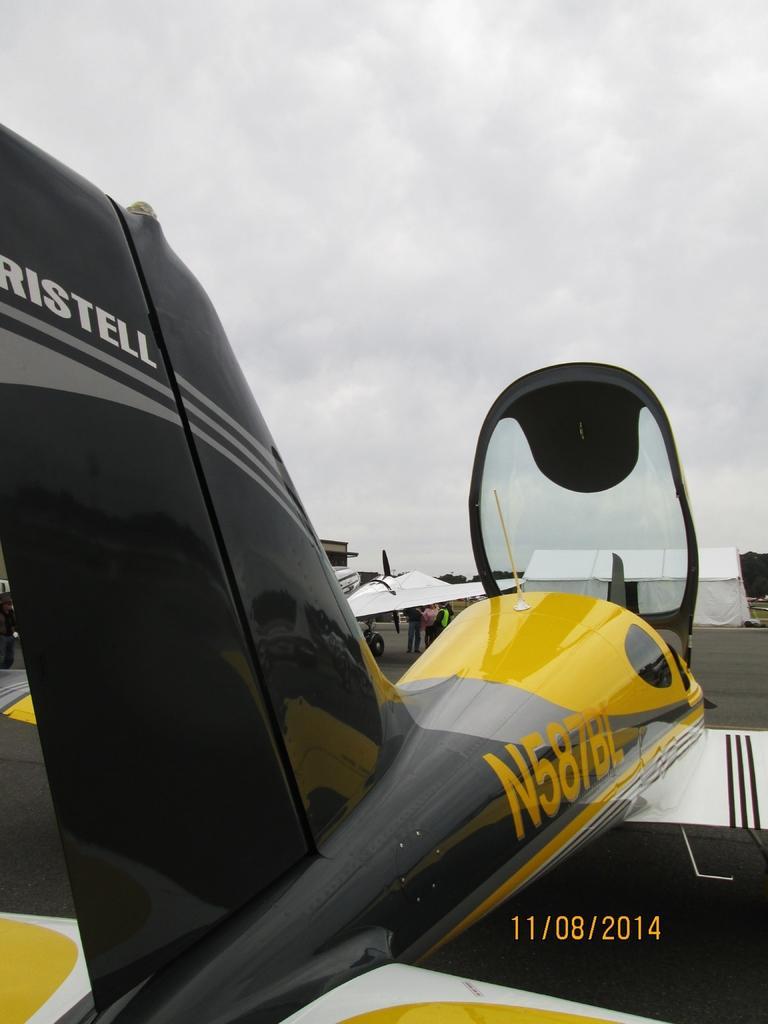Describe this image in one or two sentences. In this image there are aeroplanes on the run way in front of that there is a white tent and some people standing under the wing. 